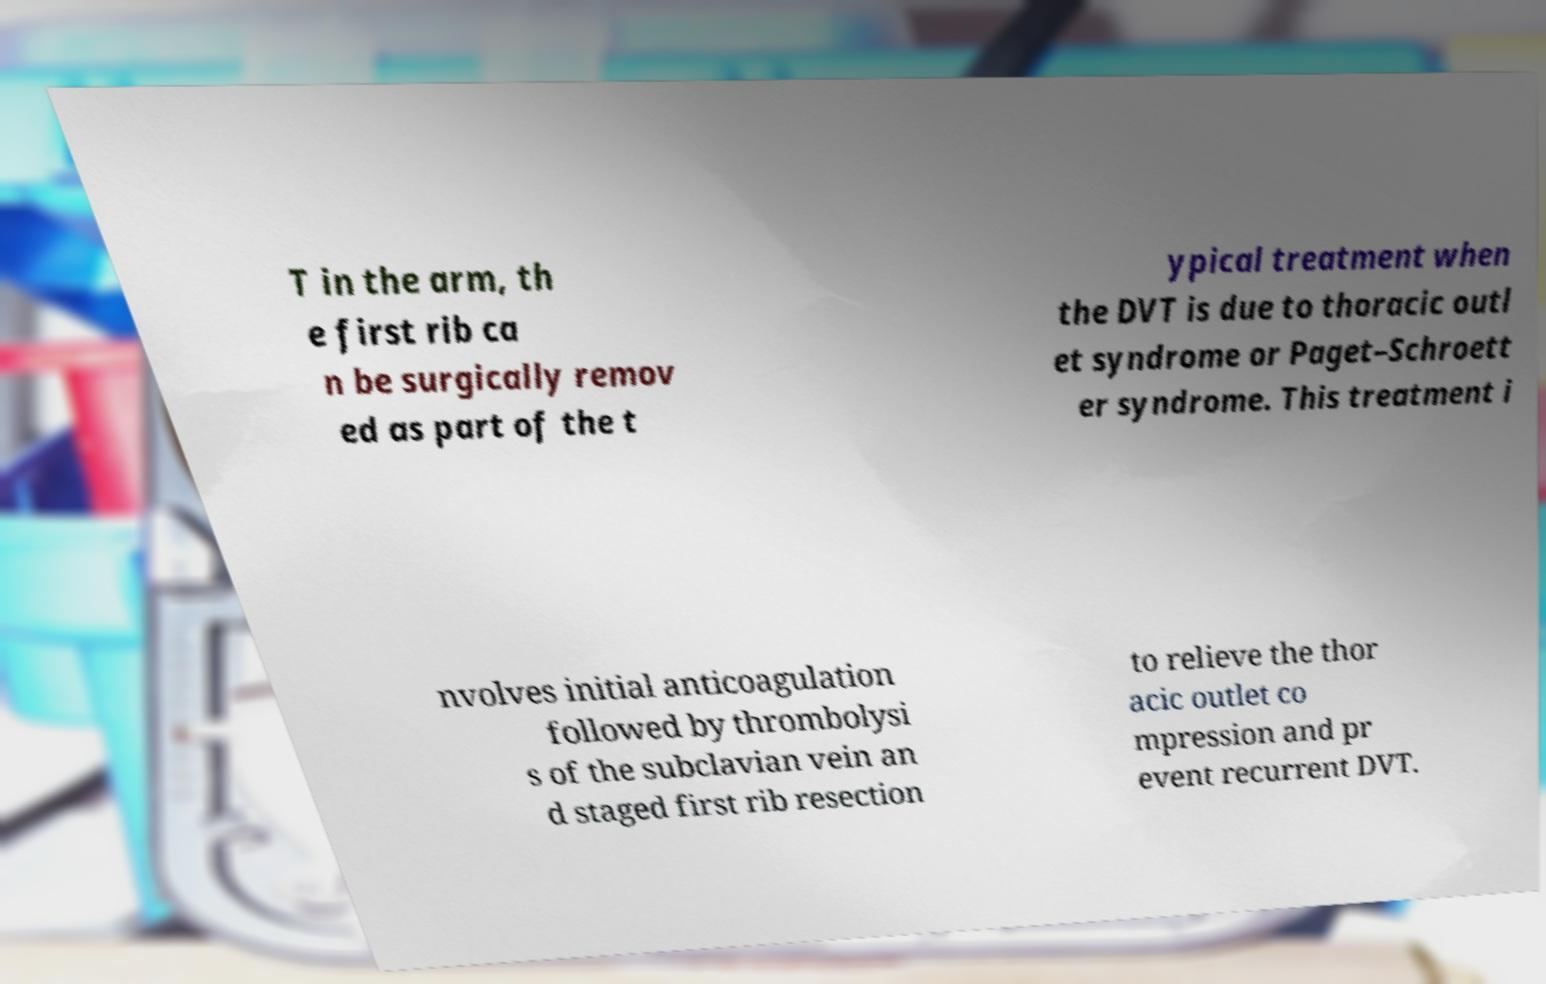Could you assist in decoding the text presented in this image and type it out clearly? T in the arm, th e first rib ca n be surgically remov ed as part of the t ypical treatment when the DVT is due to thoracic outl et syndrome or Paget–Schroett er syndrome. This treatment i nvolves initial anticoagulation followed by thrombolysi s of the subclavian vein an d staged first rib resection to relieve the thor acic outlet co mpression and pr event recurrent DVT. 